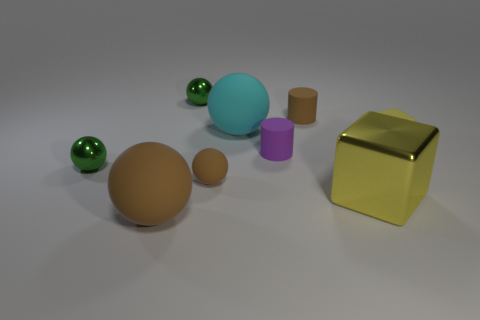There is a small sphere that is behind the metallic object to the left of the thing in front of the yellow metal object; what is its material?
Provide a succinct answer. Metal. What number of other things are made of the same material as the large cyan object?
Your answer should be compact. 5. There is a cylinder that is in front of the brown rubber cylinder; what number of small purple things are to the left of it?
Ensure brevity in your answer.  0. How many balls are either yellow objects or rubber things?
Your answer should be compact. 3. There is a rubber object that is behind the big metal block and in front of the tiny purple rubber object; what is its color?
Provide a short and direct response. Brown. The rubber thing that is right of the matte cylinder that is behind the yellow rubber thing is what color?
Your answer should be compact. Yellow. Is the size of the yellow metal block the same as the rubber cube?
Your response must be concise. No. Is the tiny green ball behind the purple matte thing made of the same material as the cylinder that is behind the large cyan object?
Provide a succinct answer. No. The small brown thing that is behind the shiny ball in front of the large rubber thing that is behind the tiny yellow rubber cube is what shape?
Provide a short and direct response. Cylinder. Is the number of small balls greater than the number of large matte balls?
Your response must be concise. Yes. 